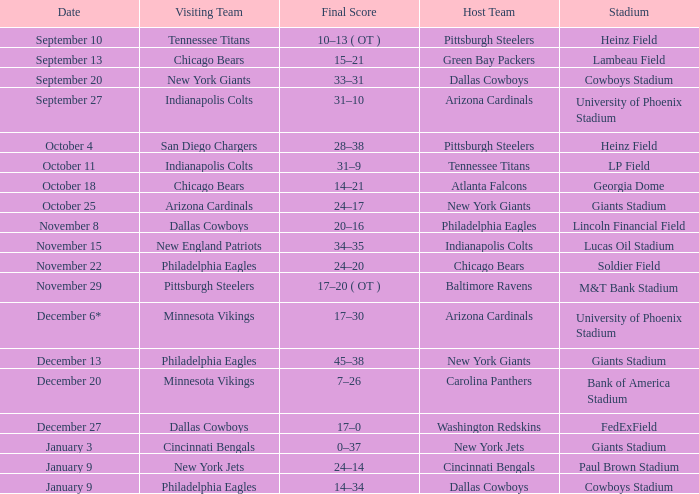Provide the ultimate score for january 9 for cincinnati bengals. 24–14. 